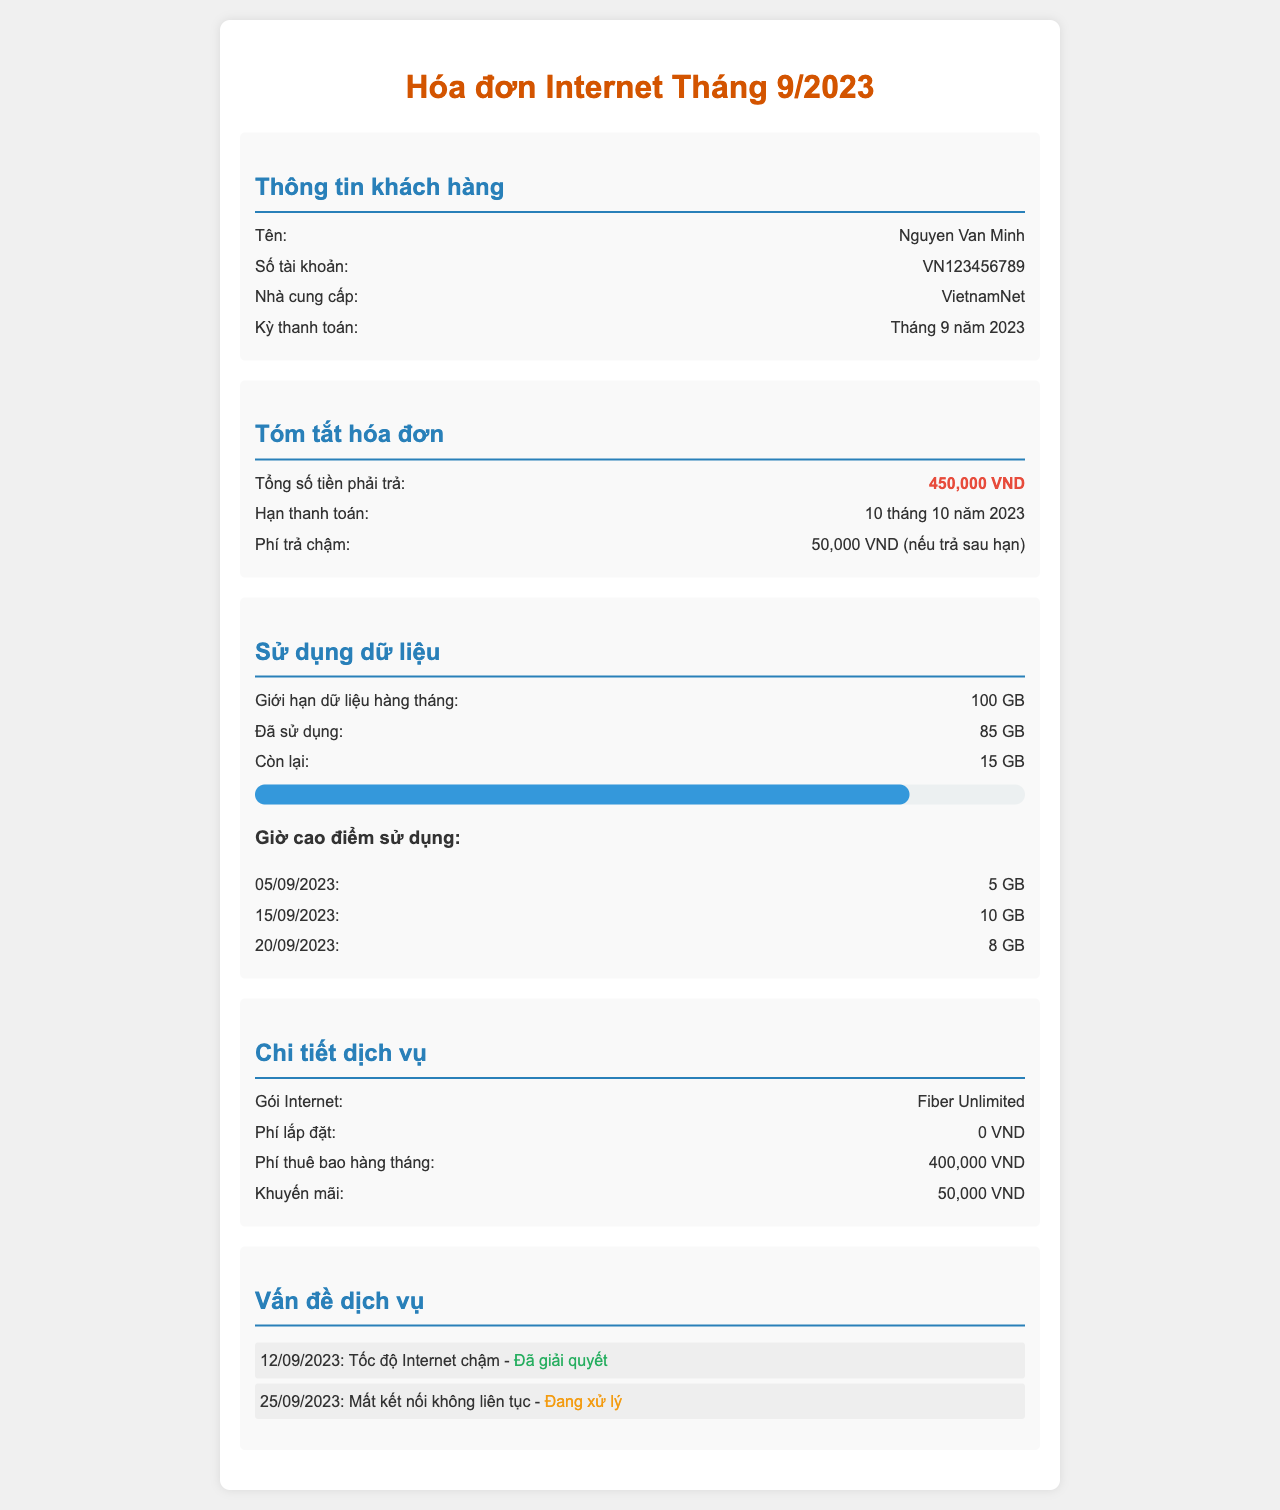What is the name of the customer? The document provides the customer's name as "Nguyen Van Minh."
Answer: Nguyen Van Minh What is the limit of monthly data usage? The document states that the monthly data usage limit is 100 GB.
Answer: 100 GB What is the total amount due? The total amount due is highlighted in the document as 450,000 VND.
Answer: 450,000 VND How much data was used on 15/09/2023? According to the data usage section, 10 GB were used on 15/09/2023.
Answer: 10 GB What is the penalty fee for late payment? The document indicates a late payment fee of 50,000 VND if paid after the due date.
Answer: 50,000 VND What is the installation fee? The document mentions that the installation fee is 0 VND.
Answer: 0 VND How much is the monthly subscription fee? The document states the monthly subscription fee is 400,000 VND.
Answer: 400,000 VND What service issue is currently pending? The document lists "Mất kết nối không liên tục" as an issue currently pending resolution.
Answer: Mất kết nối không liên tục How many gigabytes are left for the month? The document indicates that there are 15 GB remaining for the month.
Answer: 15 GB 